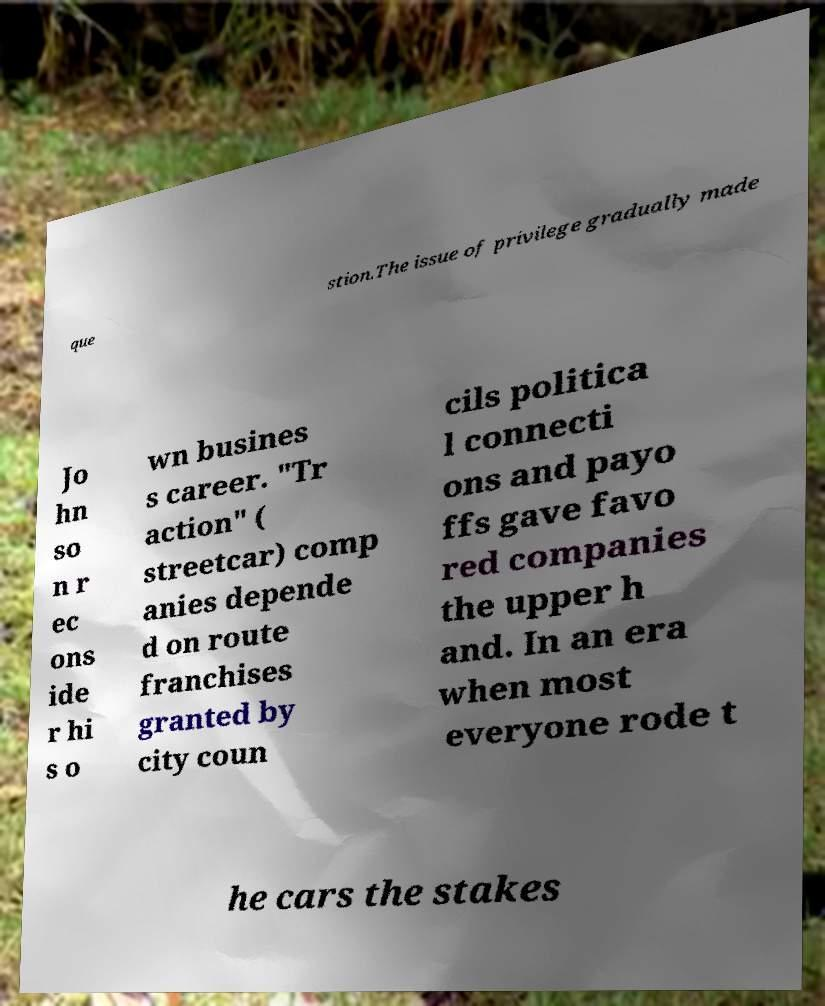Could you extract and type out the text from this image? que stion.The issue of privilege gradually made Jo hn so n r ec ons ide r hi s o wn busines s career. "Tr action" ( streetcar) comp anies depende d on route franchises granted by city coun cils politica l connecti ons and payo ffs gave favo red companies the upper h and. In an era when most everyone rode t he cars the stakes 